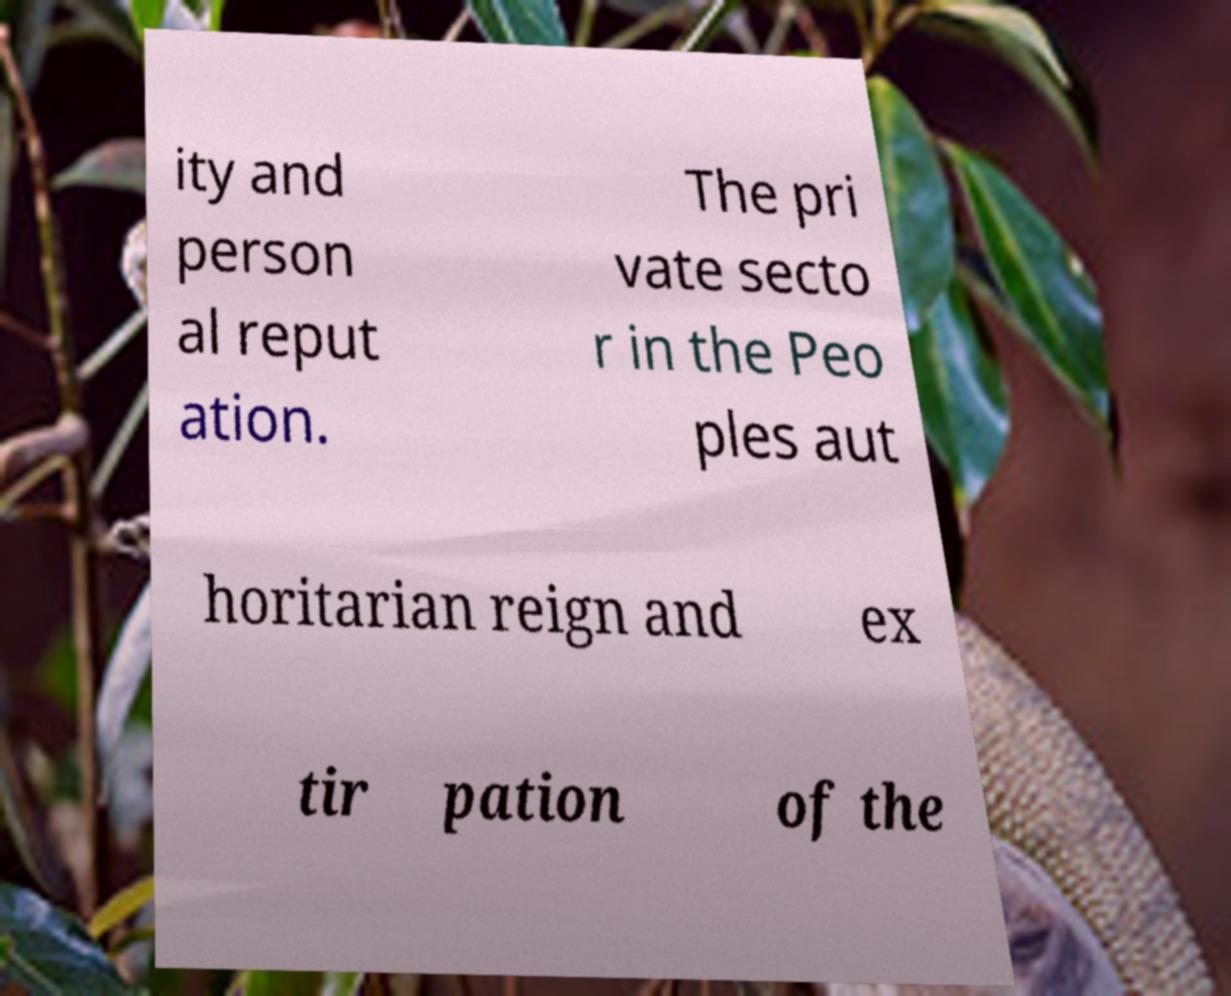For documentation purposes, I need the text within this image transcribed. Could you provide that? ity and person al reput ation. The pri vate secto r in the Peo ples aut horitarian reign and ex tir pation of the 